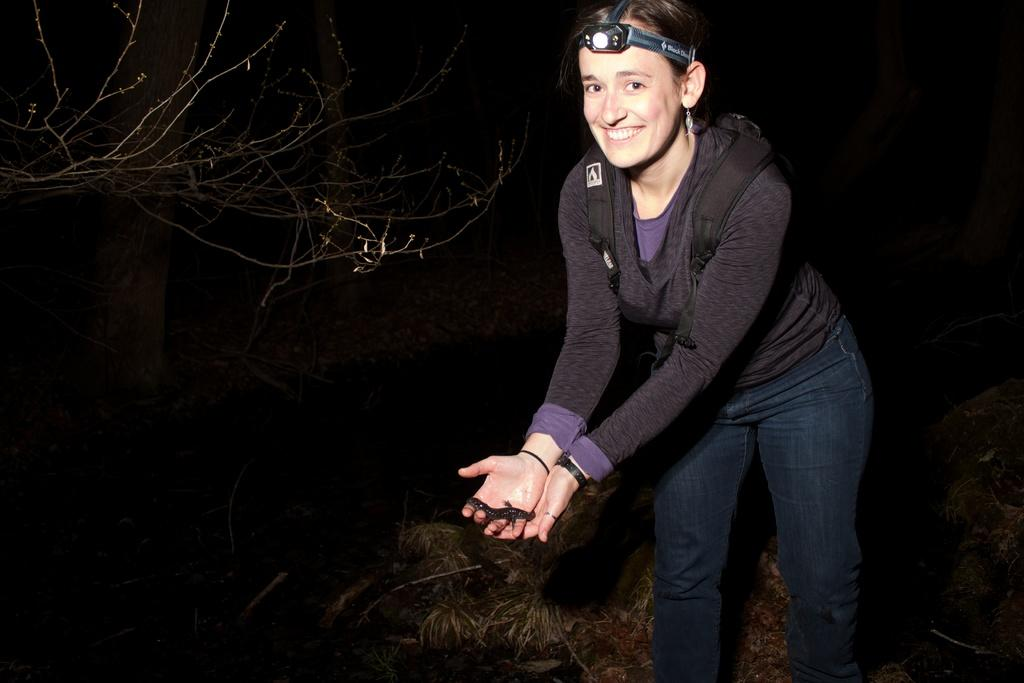Who is the main subject in the image? There is a lady in the center of the image. What is the lady holding in her hand? The lady is holding a fish in her hand. What can be seen in the background of the image? There is a tree in the background of the image. What type of vegetation is at the bottom of the image? There is grass at the bottom of the image. What is the price of the sofa in the image? There is no sofa present in the image, so it is not possible to determine its price. 